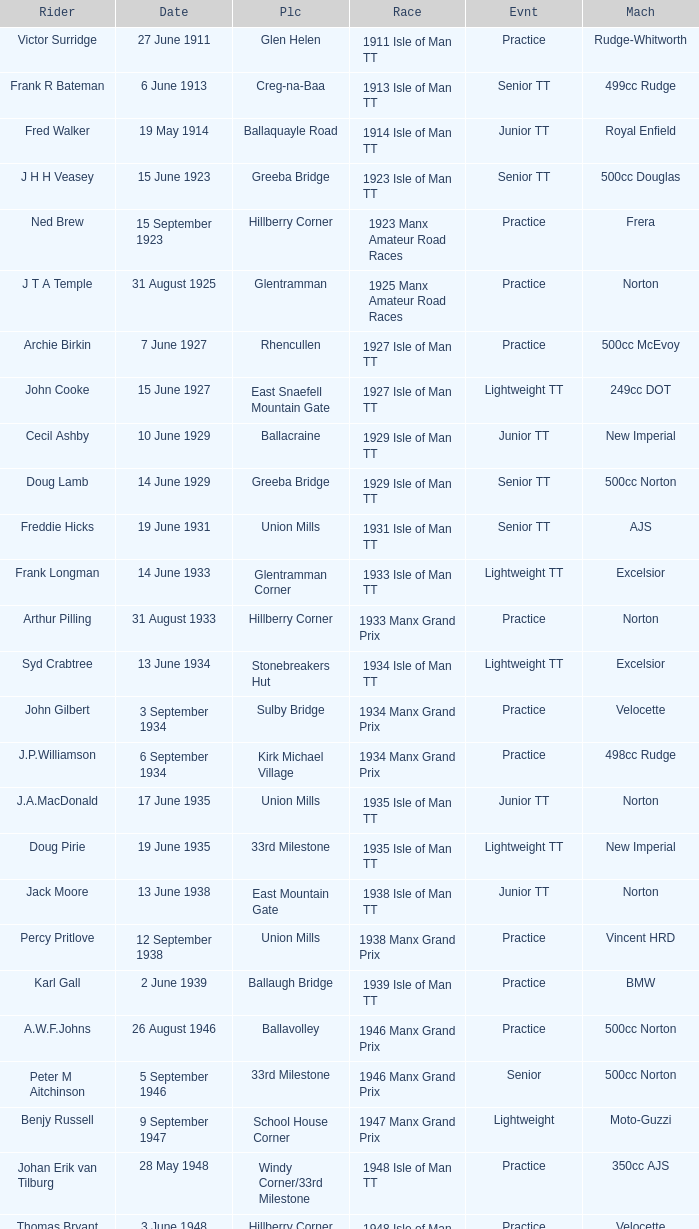Harry l Stephen rides a Norton machine on what date? 8 June 1953. 